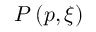<formula> <loc_0><loc_0><loc_500><loc_500>P \left ( p , \xi \right )</formula> 